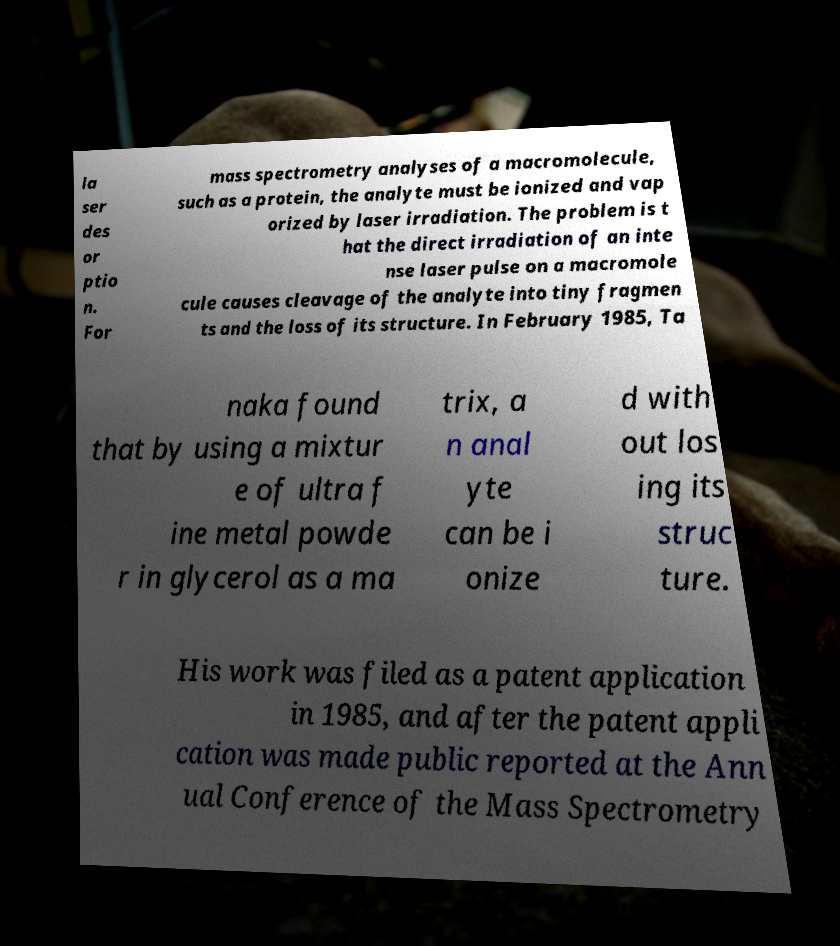What messages or text are displayed in this image? I need them in a readable, typed format. la ser des or ptio n. For mass spectrometry analyses of a macromolecule, such as a protein, the analyte must be ionized and vap orized by laser irradiation. The problem is t hat the direct irradiation of an inte nse laser pulse on a macromole cule causes cleavage of the analyte into tiny fragmen ts and the loss of its structure. In February 1985, Ta naka found that by using a mixtur e of ultra f ine metal powde r in glycerol as a ma trix, a n anal yte can be i onize d with out los ing its struc ture. His work was filed as a patent application in 1985, and after the patent appli cation was made public reported at the Ann ual Conference of the Mass Spectrometry 